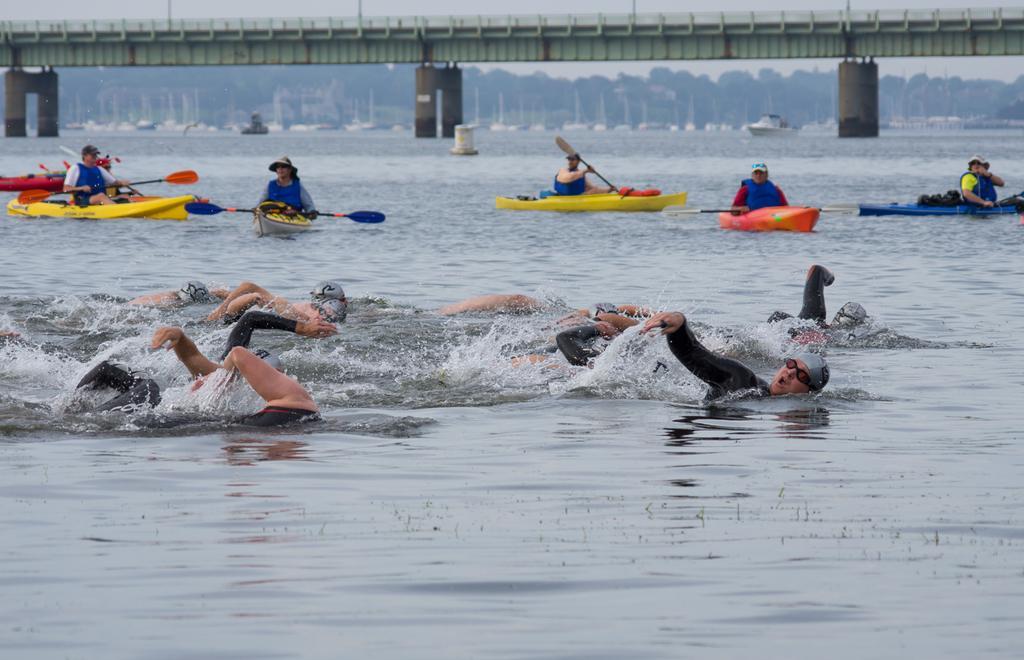Describe this image in one or two sentences. This is a sea. Here I can see few people swimming in the water towards the right side. In the background there are few people holding paddles in the hands and sitting on the boats. At the top of the image there is a bridge. In the background there are many trees and also I can see few boats on the water. 